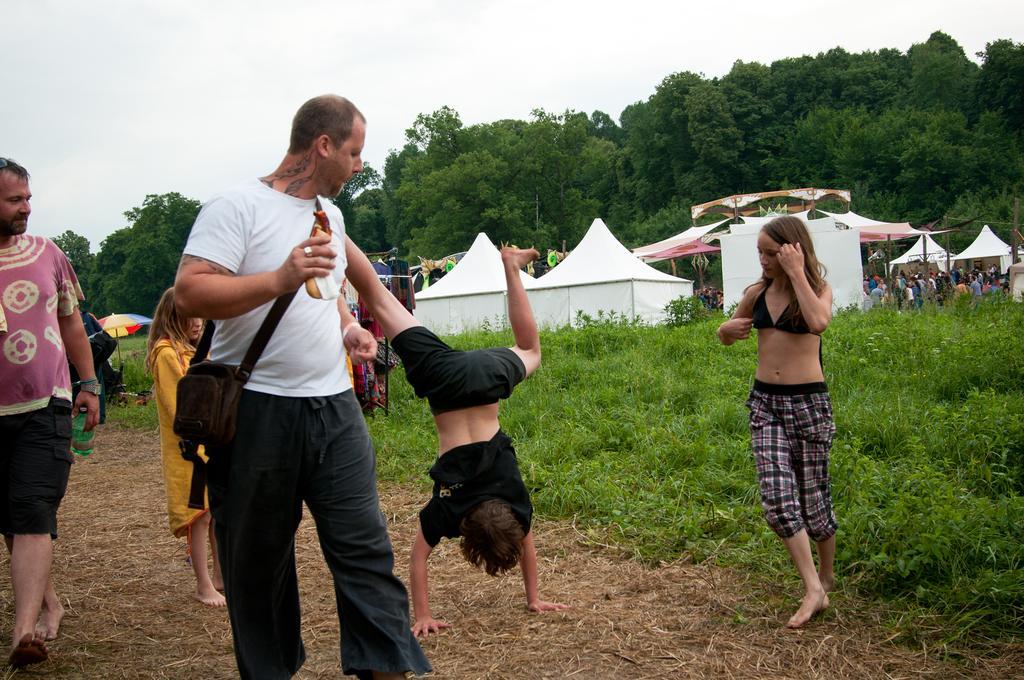Please provide a concise description of this image. In the picture there is a path, on the path there are people walking and the children playing, beside there are plants, there is an umbrella, there are tents present, near the tents there are many people present, there are trees, there is a clear sky. 